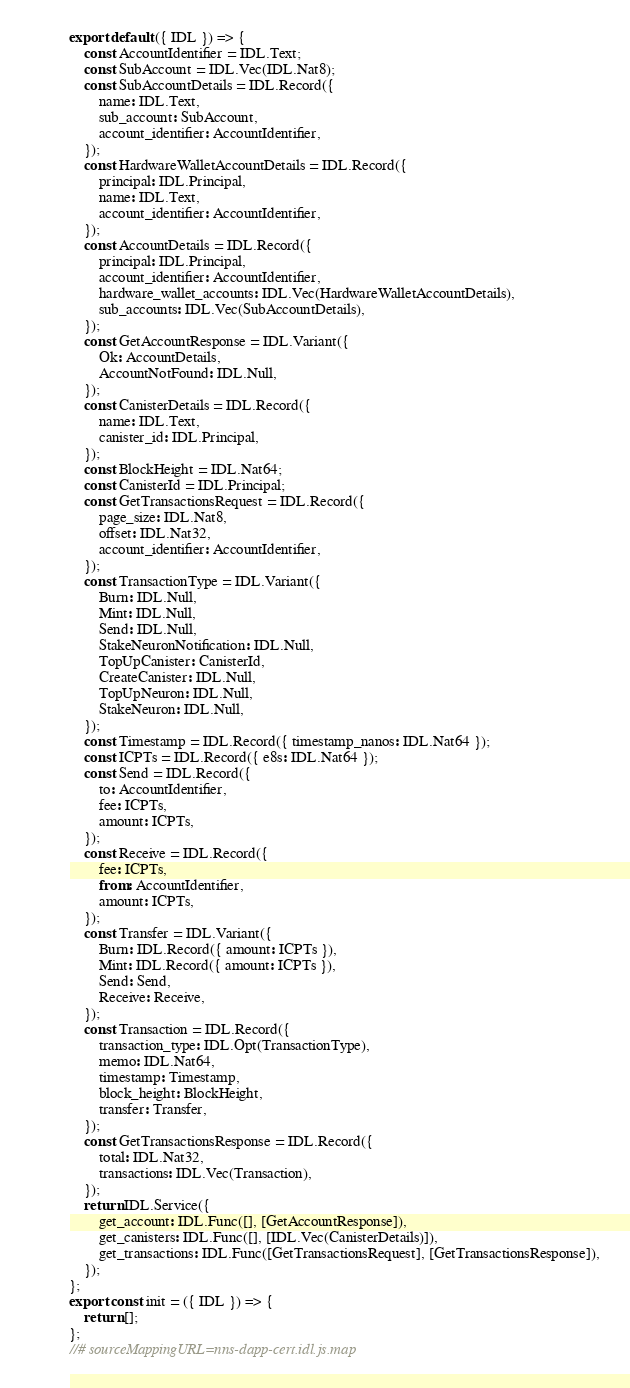<code> <loc_0><loc_0><loc_500><loc_500><_JavaScript_>export default ({ IDL }) => {
    const AccountIdentifier = IDL.Text;
    const SubAccount = IDL.Vec(IDL.Nat8);
    const SubAccountDetails = IDL.Record({
        name: IDL.Text,
        sub_account: SubAccount,
        account_identifier: AccountIdentifier,
    });
    const HardwareWalletAccountDetails = IDL.Record({
        principal: IDL.Principal,
        name: IDL.Text,
        account_identifier: AccountIdentifier,
    });
    const AccountDetails = IDL.Record({
        principal: IDL.Principal,
        account_identifier: AccountIdentifier,
        hardware_wallet_accounts: IDL.Vec(HardwareWalletAccountDetails),
        sub_accounts: IDL.Vec(SubAccountDetails),
    });
    const GetAccountResponse = IDL.Variant({
        Ok: AccountDetails,
        AccountNotFound: IDL.Null,
    });
    const CanisterDetails = IDL.Record({
        name: IDL.Text,
        canister_id: IDL.Principal,
    });
    const BlockHeight = IDL.Nat64;
    const CanisterId = IDL.Principal;
    const GetTransactionsRequest = IDL.Record({
        page_size: IDL.Nat8,
        offset: IDL.Nat32,
        account_identifier: AccountIdentifier,
    });
    const TransactionType = IDL.Variant({
        Burn: IDL.Null,
        Mint: IDL.Null,
        Send: IDL.Null,
        StakeNeuronNotification: IDL.Null,
        TopUpCanister: CanisterId,
        CreateCanister: IDL.Null,
        TopUpNeuron: IDL.Null,
        StakeNeuron: IDL.Null,
    });
    const Timestamp = IDL.Record({ timestamp_nanos: IDL.Nat64 });
    const ICPTs = IDL.Record({ e8s: IDL.Nat64 });
    const Send = IDL.Record({
        to: AccountIdentifier,
        fee: ICPTs,
        amount: ICPTs,
    });
    const Receive = IDL.Record({
        fee: ICPTs,
        from: AccountIdentifier,
        amount: ICPTs,
    });
    const Transfer = IDL.Variant({
        Burn: IDL.Record({ amount: ICPTs }),
        Mint: IDL.Record({ amount: ICPTs }),
        Send: Send,
        Receive: Receive,
    });
    const Transaction = IDL.Record({
        transaction_type: IDL.Opt(TransactionType),
        memo: IDL.Nat64,
        timestamp: Timestamp,
        block_height: BlockHeight,
        transfer: Transfer,
    });
    const GetTransactionsResponse = IDL.Record({
        total: IDL.Nat32,
        transactions: IDL.Vec(Transaction),
    });
    return IDL.Service({
        get_account: IDL.Func([], [GetAccountResponse]),
        get_canisters: IDL.Func([], [IDL.Vec(CanisterDetails)]),
        get_transactions: IDL.Func([GetTransactionsRequest], [GetTransactionsResponse]),
    });
};
export const init = ({ IDL }) => {
    return [];
};
//# sourceMappingURL=nns-dapp-cert.idl.js.map</code> 